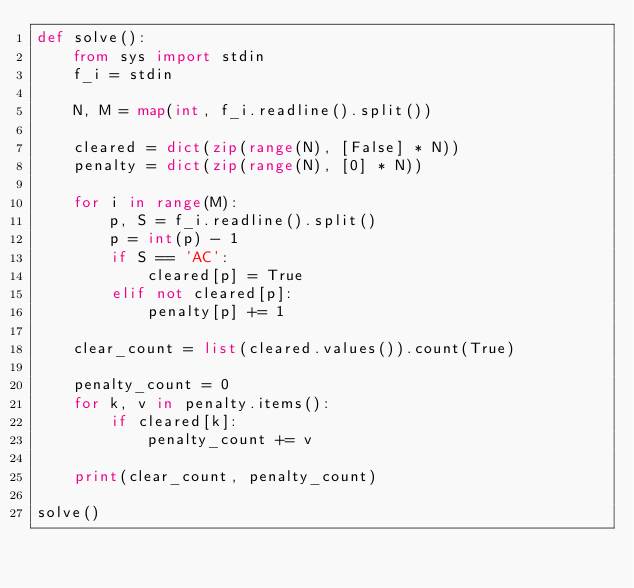Convert code to text. <code><loc_0><loc_0><loc_500><loc_500><_Python_>def solve():
    from sys import stdin
    f_i = stdin
    
    N, M = map(int, f_i.readline().split())
    
    cleared = dict(zip(range(N), [False] * N))
    penalty = dict(zip(range(N), [0] * N))
    
    for i in range(M):
        p, S = f_i.readline().split()
        p = int(p) - 1
        if S == 'AC':
            cleared[p] = True
        elif not cleared[p]:
            penalty[p] += 1
    
    clear_count = list(cleared.values()).count(True)
    
    penalty_count = 0
    for k, v in penalty.items():
        if cleared[k]:
            penalty_count += v
    
    print(clear_count, penalty_count)

solve()</code> 